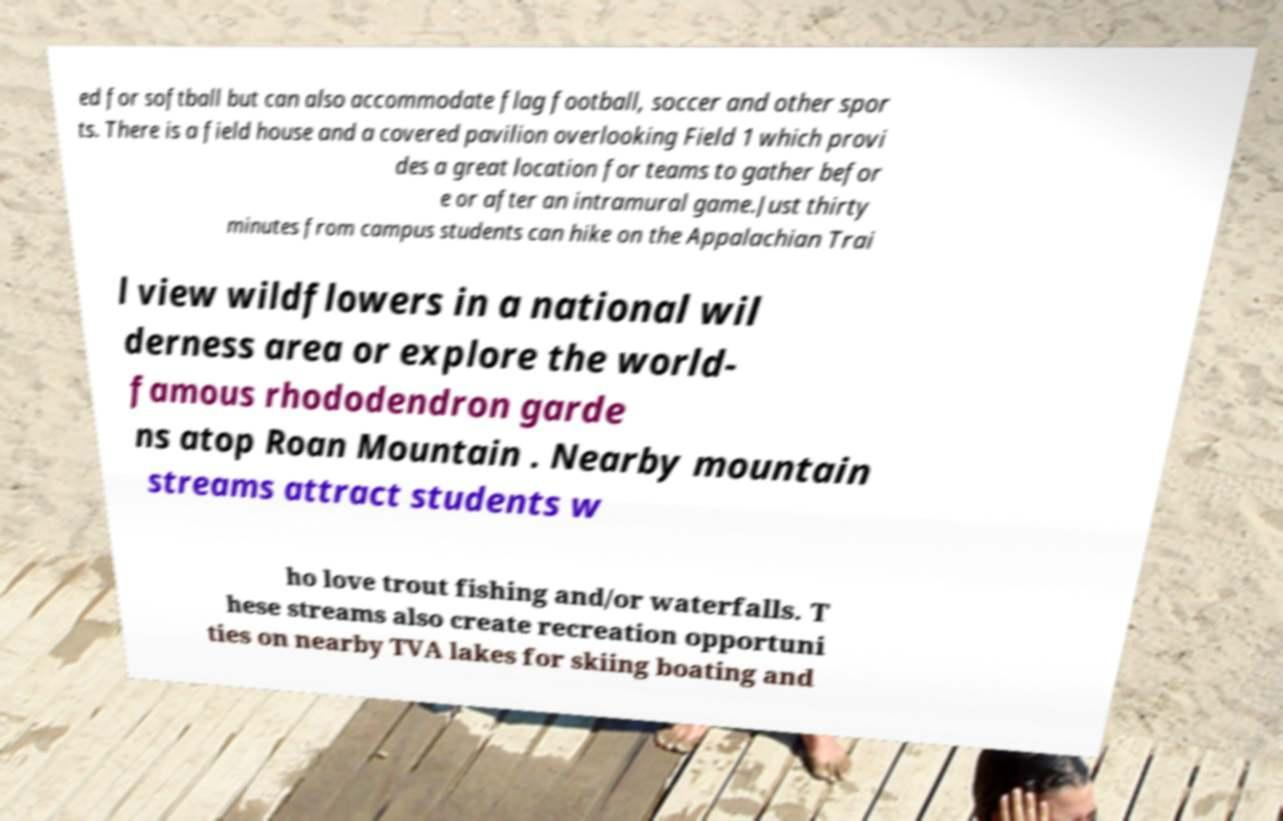Could you assist in decoding the text presented in this image and type it out clearly? ed for softball but can also accommodate flag football, soccer and other spor ts. There is a field house and a covered pavilion overlooking Field 1 which provi des a great location for teams to gather befor e or after an intramural game.Just thirty minutes from campus students can hike on the Appalachian Trai l view wildflowers in a national wil derness area or explore the world- famous rhododendron garde ns atop Roan Mountain . Nearby mountain streams attract students w ho love trout fishing and/or waterfalls. T hese streams also create recreation opportuni ties on nearby TVA lakes for skiing boating and 